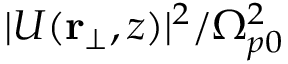Convert formula to latex. <formula><loc_0><loc_0><loc_500><loc_500>| U ( r _ { \bot } , z ) | ^ { 2 } / \Omega _ { p 0 } ^ { 2 }</formula> 